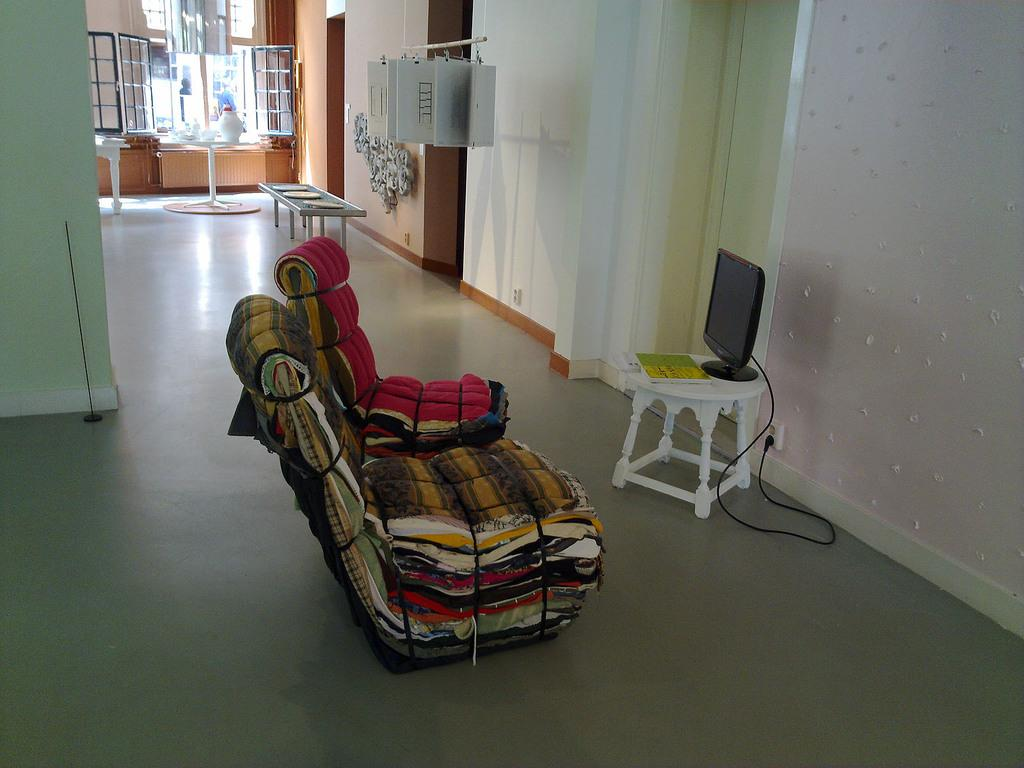What type of furniture can be seen in the image? There are chairs and tables in the image. What object related to reading is present in the image? There is a book in the image. What type of electronic device is visible in the image? There is a television in the image. What type of seating is available in the image that is not a chair? There is a bench in the image. What architectural feature allows natural light to enter the room? There are windows in the image. What type of decorative object is present in the image? There is a vase in the image. What can be inferred about the presence of objects in the image? There are objects in the image, as mentioned in the facts. What part of the room is visible in the image? The floor and walls are visible in the image. Where is the zoo located in the image? There is no zoo present in the image. What type of tool is being used to hammer nails in the image? There is no hammer or any indication of hammering in the image. 